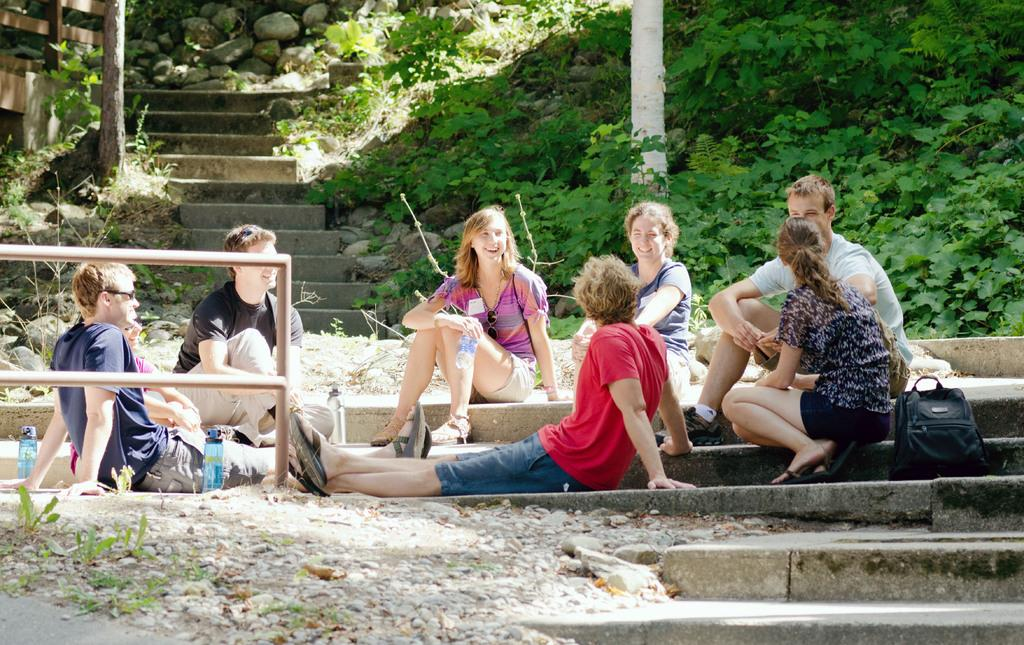What is happening in the image? There are many people sitting in the image. What is at the bottom of the image? There is a ground at the bottom of the image. What can be seen in the background of the image? There are steps, plants, and rocks in the background of the image. What type of lumber is being used to build the pear tree in the morning? There is no lumber, pear tree, or morning mentioned in the image. The image only shows people sitting and the background elements. 